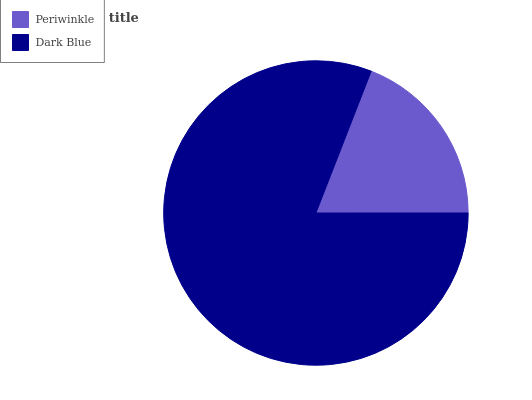Is Periwinkle the minimum?
Answer yes or no. Yes. Is Dark Blue the maximum?
Answer yes or no. Yes. Is Dark Blue the minimum?
Answer yes or no. No. Is Dark Blue greater than Periwinkle?
Answer yes or no. Yes. Is Periwinkle less than Dark Blue?
Answer yes or no. Yes. Is Periwinkle greater than Dark Blue?
Answer yes or no. No. Is Dark Blue less than Periwinkle?
Answer yes or no. No. Is Dark Blue the high median?
Answer yes or no. Yes. Is Periwinkle the low median?
Answer yes or no. Yes. Is Periwinkle the high median?
Answer yes or no. No. Is Dark Blue the low median?
Answer yes or no. No. 